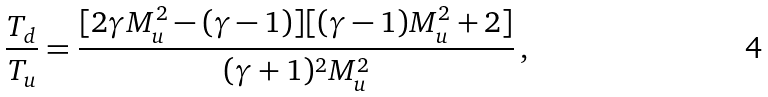Convert formula to latex. <formula><loc_0><loc_0><loc_500><loc_500>\frac { T _ { d } } { T _ { u } } = \frac { [ 2 \gamma M _ { u } ^ { 2 } - ( \gamma - 1 ) ] [ ( \gamma - 1 ) M _ { u } ^ { 2 } + 2 ] } { ( \gamma + 1 ) ^ { 2 } M _ { u } ^ { 2 } } \, ,</formula> 